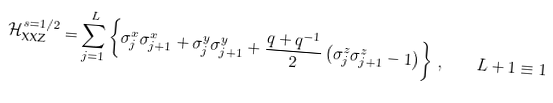<formula> <loc_0><loc_0><loc_500><loc_500>\mathcal { H } _ { \text {XXZ} } ^ { s = 1 / 2 } = \sum _ { j = 1 } ^ { L } \left \{ \sigma _ { j } ^ { x } \sigma _ { j + 1 } ^ { x } + \sigma _ { j } ^ { y } \sigma _ { j + 1 } ^ { y } + \frac { q + q ^ { - 1 } } { 2 } \left ( \sigma _ { j } ^ { z } \sigma _ { j + 1 } ^ { z } - 1 \right ) \right \} \, , \quad L + 1 \equiv 1</formula> 